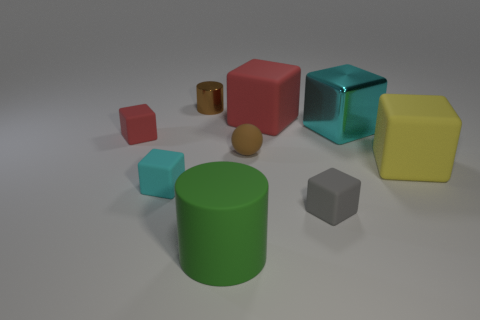What number of other objects are the same material as the small cyan object?
Your response must be concise. 6. What is the shape of the shiny object that is the same color as the sphere?
Provide a short and direct response. Cylinder. There is a cylinder in front of the yellow rubber object; what size is it?
Your answer should be compact. Large. There is a green thing that is the same material as the tiny gray cube; what shape is it?
Offer a very short reply. Cylinder. Is the material of the green cylinder the same as the cyan cube behind the yellow matte thing?
Provide a succinct answer. No. There is a big rubber object in front of the gray rubber cube; is it the same shape as the tiny brown matte object?
Make the answer very short. No. There is a large cyan thing that is the same shape as the large yellow matte object; what is its material?
Make the answer very short. Metal. Does the yellow thing have the same shape as the red object on the right side of the rubber cylinder?
Keep it short and to the point. Yes. What is the color of the big matte thing that is both in front of the tiny red block and on the right side of the rubber ball?
Your response must be concise. Yellow. Is there a small brown matte sphere?
Offer a very short reply. Yes. 